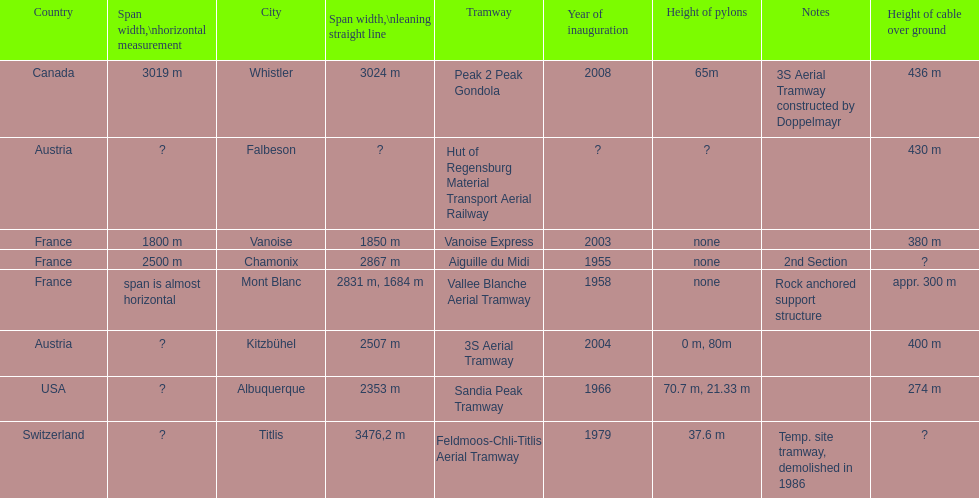How much greater is the height of cable over ground measurement for the peak 2 peak gondola when compared with that of the vanoise express? 56 m. 